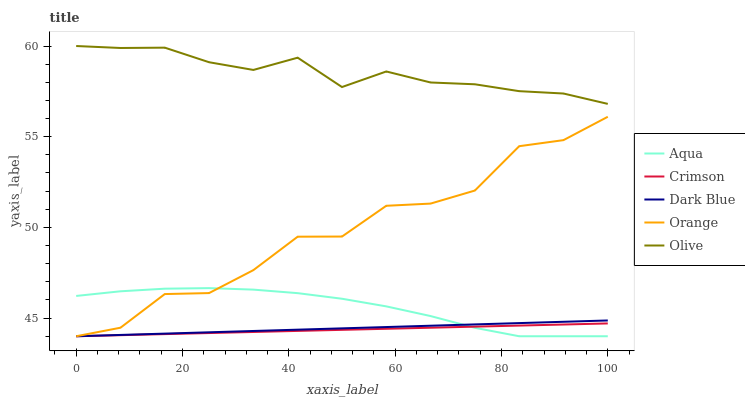Does Crimson have the minimum area under the curve?
Answer yes or no. Yes. Does Olive have the maximum area under the curve?
Answer yes or no. Yes. Does Dark Blue have the minimum area under the curve?
Answer yes or no. No. Does Dark Blue have the maximum area under the curve?
Answer yes or no. No. Is Crimson the smoothest?
Answer yes or no. Yes. Is Orange the roughest?
Answer yes or no. Yes. Is Dark Blue the smoothest?
Answer yes or no. No. Is Dark Blue the roughest?
Answer yes or no. No. Does Olive have the lowest value?
Answer yes or no. No. Does Dark Blue have the highest value?
Answer yes or no. No. Is Orange less than Olive?
Answer yes or no. Yes. Is Olive greater than Orange?
Answer yes or no. Yes. Does Orange intersect Olive?
Answer yes or no. No. 